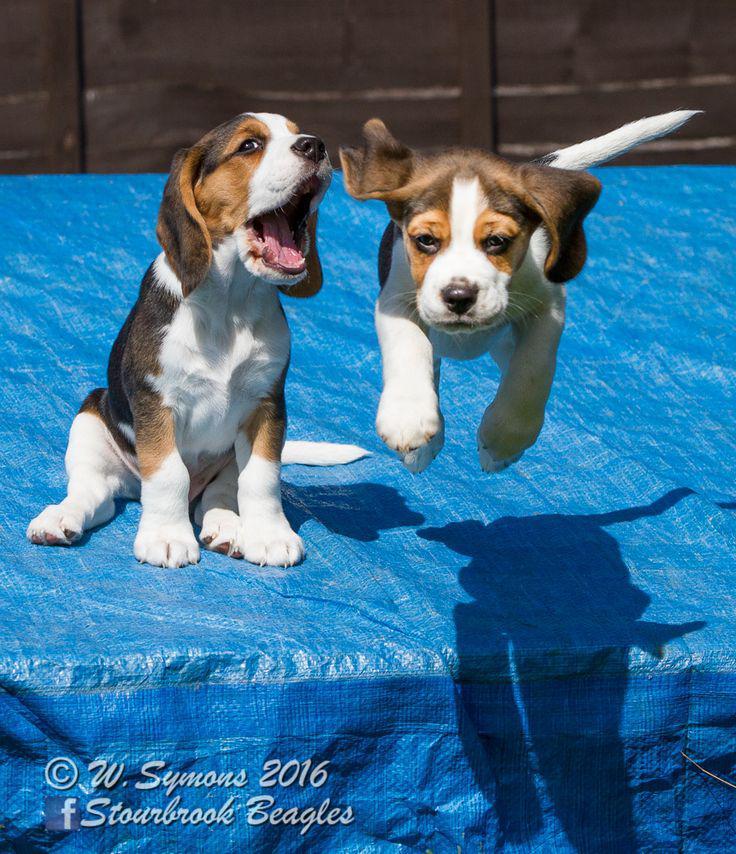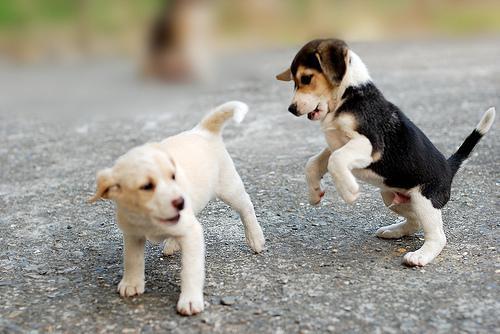The first image is the image on the left, the second image is the image on the right. Considering the images on both sides, is "An equal number of puppies are shown in each image at an outdoor location, one of them with its front paws in mid- air." valid? Answer yes or no. Yes. The first image is the image on the left, the second image is the image on the right. Considering the images on both sides, is "There are equal amount of dogs in the left image as the right." valid? Answer yes or no. Yes. 